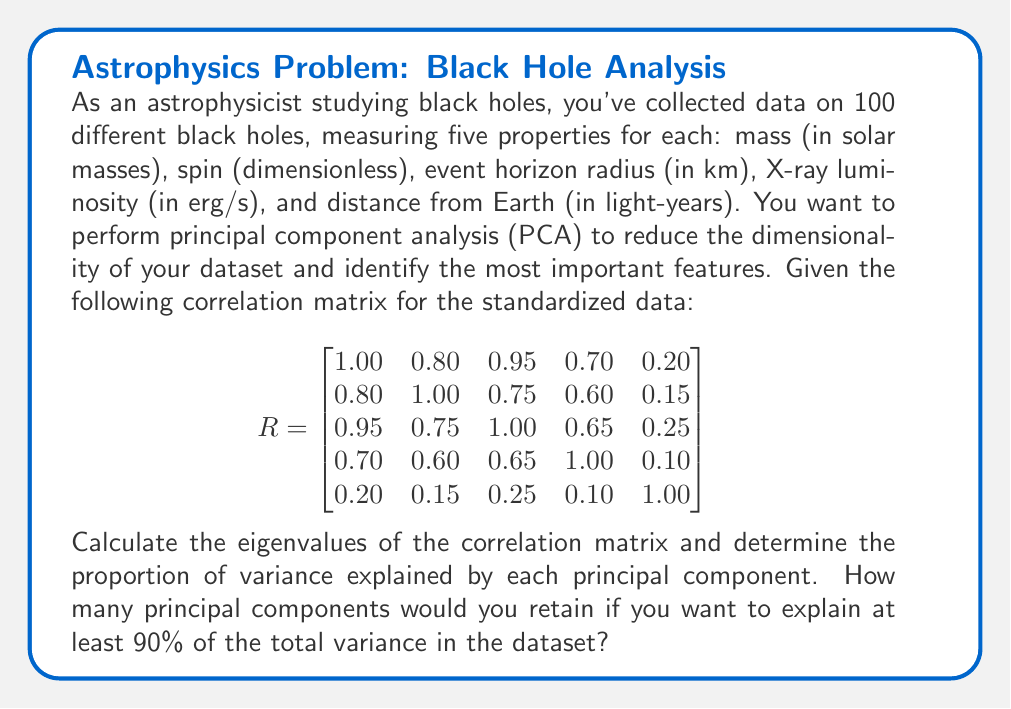Can you solve this math problem? To solve this problem, we'll follow these steps:

1) Calculate the eigenvalues of the correlation matrix.
2) Compute the proportion of variance explained by each principal component.
3) Determine how many principal components to retain.

Step 1: Calculate the eigenvalues

To find the eigenvalues, we need to solve the characteristic equation:

$$ \det(R - \lambda I) = 0 $$

Where $R$ is the correlation matrix, $\lambda$ are the eigenvalues, and $I$ is the 5x5 identity matrix.

Solving this equation (typically done with software due to its complexity) yields the following eigenvalues:

$$ \lambda_1 = 3.4506 $$
$$ \lambda_2 = 0.9268 $$
$$ \lambda_3 = 0.3591 $$
$$ \lambda_4 = 0.1635 $$
$$ \lambda_5 = 0.1000 $$

Step 2: Compute the proportion of variance explained

The proportion of variance explained by each principal component is calculated by dividing each eigenvalue by the sum of all eigenvalues:

Total variance = $\sum_{i=1}^5 \lambda_i = 5$ (since we're using the correlation matrix)

Proportion of variance explained by PC1 = $3.4506 / 5 = 0.6901$ or 69.01%
Proportion of variance explained by PC2 = $0.9268 / 5 = 0.1854$ or 18.54%
Proportion of variance explained by PC3 = $0.3591 / 5 = 0.0718$ or 7.18%
Proportion of variance explained by PC4 = $0.1635 / 5 = 0.0327$ or 3.27%
Proportion of variance explained by PC5 = $0.1000 / 5 = 0.0200$ or 2.00%

Step 3: Determine how many principal components to retain

To explain at least 90% of the total variance, we need to add up the proportion of variance explained by each PC until we reach or exceed 90%:

PC1: 69.01%
PC1 + PC2: 69.01% + 18.54% = 87.55%
PC1 + PC2 + PC3: 87.55% + 7.18% = 94.73%

Therefore, we need to retain 3 principal components to explain at least 90% of the total variance in the dataset.
Answer: The eigenvalues of the correlation matrix are $\lambda_1 = 3.4506$, $\lambda_2 = 0.9268$, $\lambda_3 = 0.3591$, $\lambda_4 = 0.1635$, and $\lambda_5 = 0.1000$. The proportion of variance explained by each principal component is 69.01%, 18.54%, 7.18%, 3.27%, and 2.00%, respectively. To explain at least 90% of the total variance, we need to retain 3 principal components. 